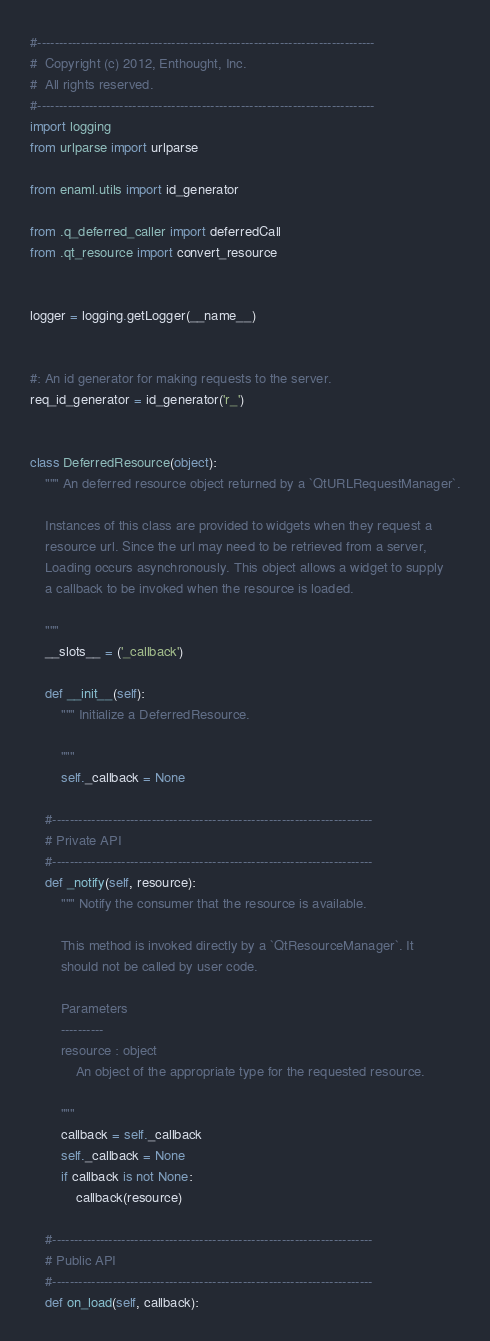<code> <loc_0><loc_0><loc_500><loc_500><_Python_>#------------------------------------------------------------------------------
#  Copyright (c) 2012, Enthought, Inc.
#  All rights reserved.
#------------------------------------------------------------------------------
import logging
from urlparse import urlparse

from enaml.utils import id_generator

from .q_deferred_caller import deferredCall
from .qt_resource import convert_resource


logger = logging.getLogger(__name__)


#: An id generator for making requests to the server.
req_id_generator = id_generator('r_')


class DeferredResource(object):
    """ An deferred resource object returned by a `QtURLRequestManager`.

    Instances of this class are provided to widgets when they request a
    resource url. Since the url may need to be retrieved from a server,
    Loading occurs asynchronously. This object allows a widget to supply
    a callback to be invoked when the resource is loaded.

    """
    __slots__ = ('_callback')

    def __init__(self):
        """ Initialize a DeferredResource.

        """
        self._callback = None

    #--------------------------------------------------------------------------
    # Private API
    #--------------------------------------------------------------------------
    def _notify(self, resource):
        """ Notify the consumer that the resource is available.

        This method is invoked directly by a `QtResourceManager`. It
        should not be called by user code.

        Parameters
        ----------
        resource : object
            An object of the appropriate type for the requested resource.

        """
        callback = self._callback
        self._callback = None
        if callback is not None:
            callback(resource)

    #--------------------------------------------------------------------------
    # Public API
    #--------------------------------------------------------------------------
    def on_load(self, callback):</code> 